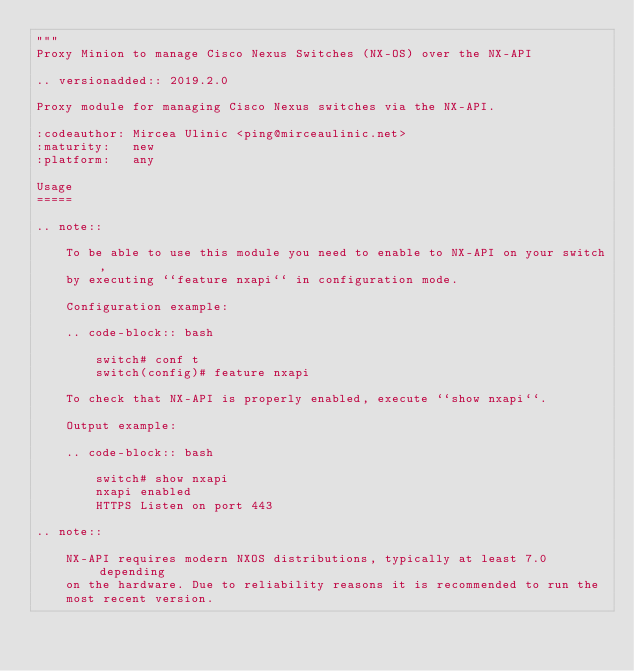<code> <loc_0><loc_0><loc_500><loc_500><_Python_>"""
Proxy Minion to manage Cisco Nexus Switches (NX-OS) over the NX-API

.. versionadded:: 2019.2.0

Proxy module for managing Cisco Nexus switches via the NX-API.

:codeauthor: Mircea Ulinic <ping@mirceaulinic.net>
:maturity:   new
:platform:   any

Usage
=====

.. note::

    To be able to use this module you need to enable to NX-API on your switch,
    by executing ``feature nxapi`` in configuration mode.

    Configuration example:

    .. code-block:: bash

        switch# conf t
        switch(config)# feature nxapi

    To check that NX-API is properly enabled, execute ``show nxapi``.

    Output example:

    .. code-block:: bash

        switch# show nxapi
        nxapi enabled
        HTTPS Listen on port 443

.. note::

    NX-API requires modern NXOS distributions, typically at least 7.0 depending
    on the hardware. Due to reliability reasons it is recommended to run the
    most recent version.
</code> 